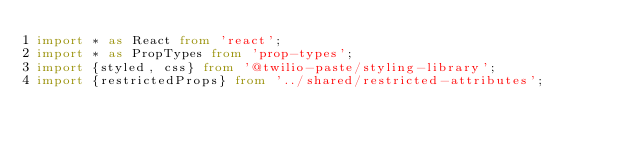Convert code to text. <code><loc_0><loc_0><loc_500><loc_500><_TypeScript_>import * as React from 'react';
import * as PropTypes from 'prop-types';
import {styled, css} from '@twilio-paste/styling-library';
import {restrictedProps} from '../shared/restricted-attributes';
</code> 